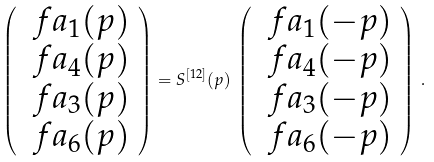Convert formula to latex. <formula><loc_0><loc_0><loc_500><loc_500>\left ( \begin{array} { c } \ f a _ { 1 } ( p ) \\ \ f a _ { 4 } ( p ) \\ \ f a _ { 3 } ( p ) \\ \ f a _ { 6 } ( p ) \end{array} \right ) = S ^ { [ 1 2 ] } ( p ) \, \left ( \begin{array} { c } \ f a _ { 1 } ( - p ) \\ \ f a _ { 4 } ( - p ) \\ \ f a _ { 3 } ( - p ) \\ \ f a _ { 6 } ( - p ) \end{array} \right ) \, .</formula> 